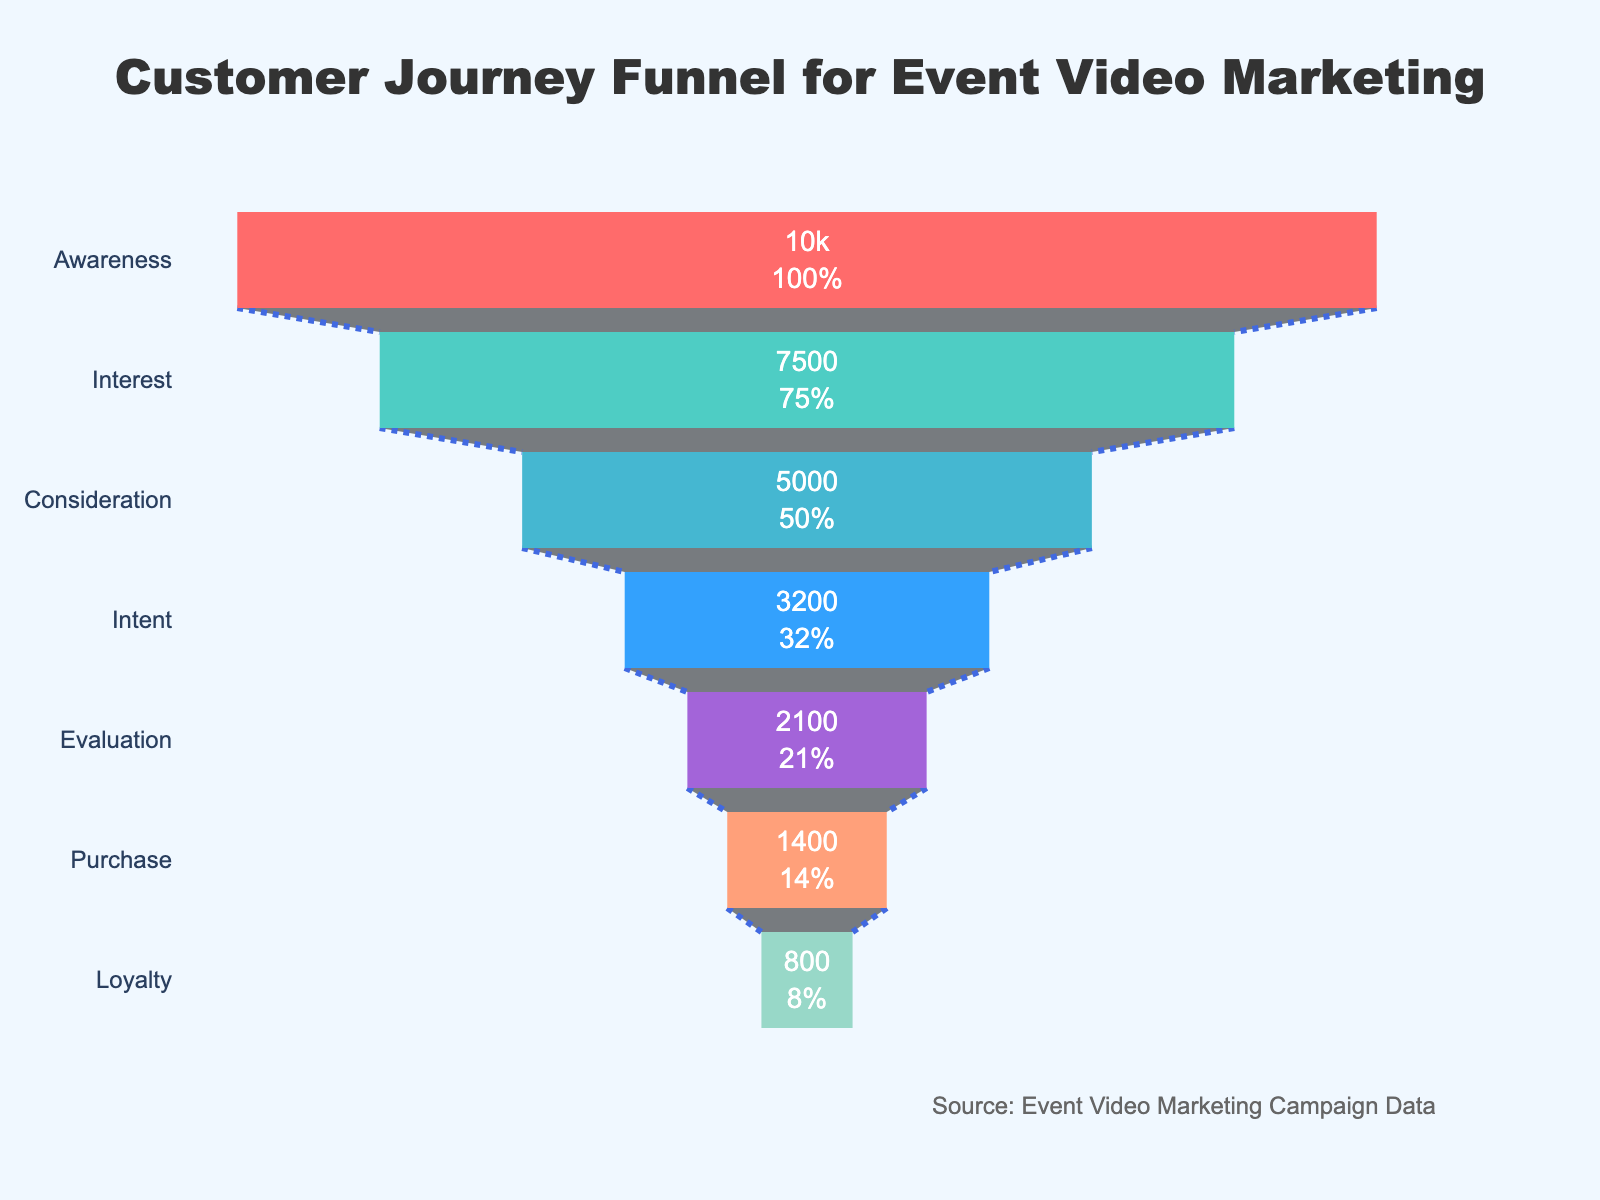What is the title of the chart? The title is written at the top of the chart and states the purpose of the chart.
Answer: Customer Journey Funnel for Event Video Marketing What are the stages in the customer journey? The stages are listed on the y-axis of the funnel chart in descending order.
Answer: Awareness, Interest, Consideration, Intent, Evaluation, Purchase, Loyalty What are the colors used to represent the different stages? The color sections of the funnel chart can be identified by looking at each segment.
Answer: Red, Green, Light Blue, Dark Blue, Purple, Light Salmon, Light Green How many viewers are in the Interest stage? The number of viewers is listed inside the segment for the Interest stage.
Answer: 7,500 What percentage of initial viewers reached the Evaluation stage? The percentage is labeled inside the Evaluation stage of the funnel chart.
Answer: 21% How many more viewers are in the Interest stage than the Intent stage? Subtract the number of viewers in the Intent stage from the Interest stage to find the difference.
Answer: 4,300 Which stage has the fewest number of viewers? Identify the segment with the smallest value on the x-axis.
Answer: Loyalty What is the difference in the number of viewers between the Awareness and Purchase stages? Subtract the number of viewers in the Purchase stage from the Awareness stage to find the difference.
Answer: 8,600 What is the total number of viewers that reached either the Evaluation or Loyalty stages? Add the number of viewers in the Evaluation stage to the number of viewers in the Loyalty stage.
Answer: 2,900 Is the drop from Consideration to Intent larger than the drop from Intent to Evaluation? Calculate the difference between stages and compare the values to determine which drop is larger.
Answer: Yes 